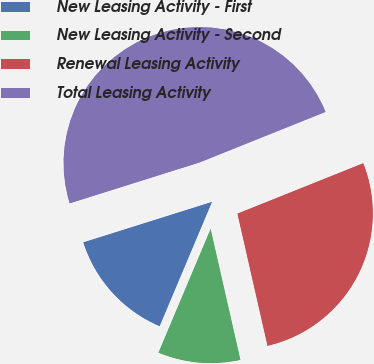Convert chart. <chart><loc_0><loc_0><loc_500><loc_500><pie_chart><fcel>New Leasing Activity - First<fcel>New Leasing Activity - Second<fcel>Renewal Leasing Activity<fcel>Total Leasing Activity<nl><fcel>13.8%<fcel>9.91%<fcel>27.51%<fcel>48.78%<nl></chart> 